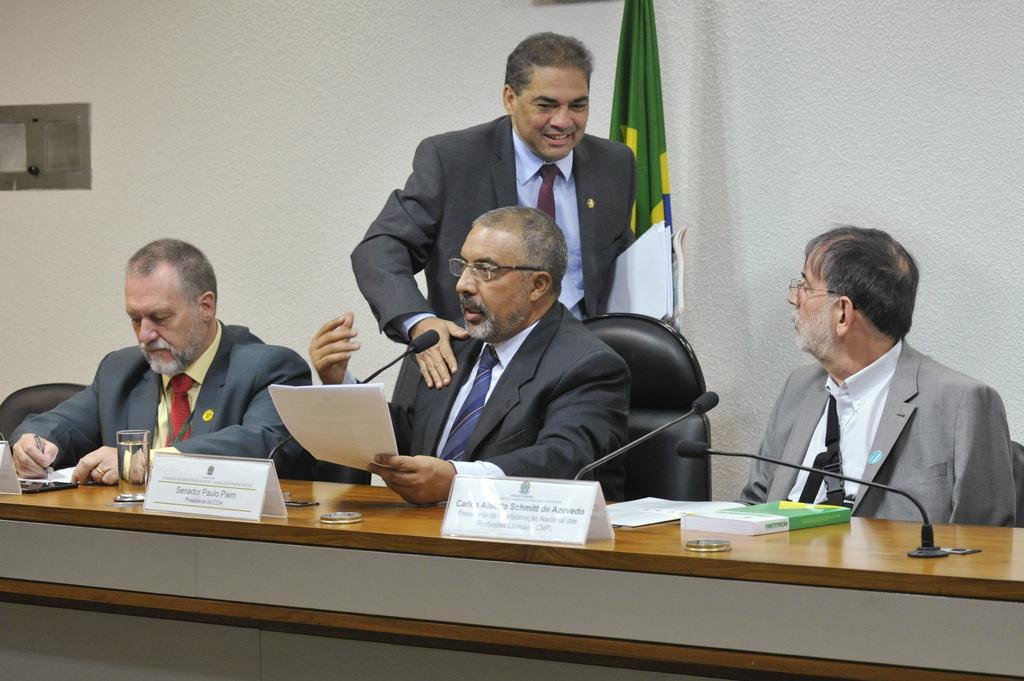Can you describe this image briefly? In this picture we can see three people sitting on the chair in front of the desk on which there are some things, glasses and behind them there is a man. 